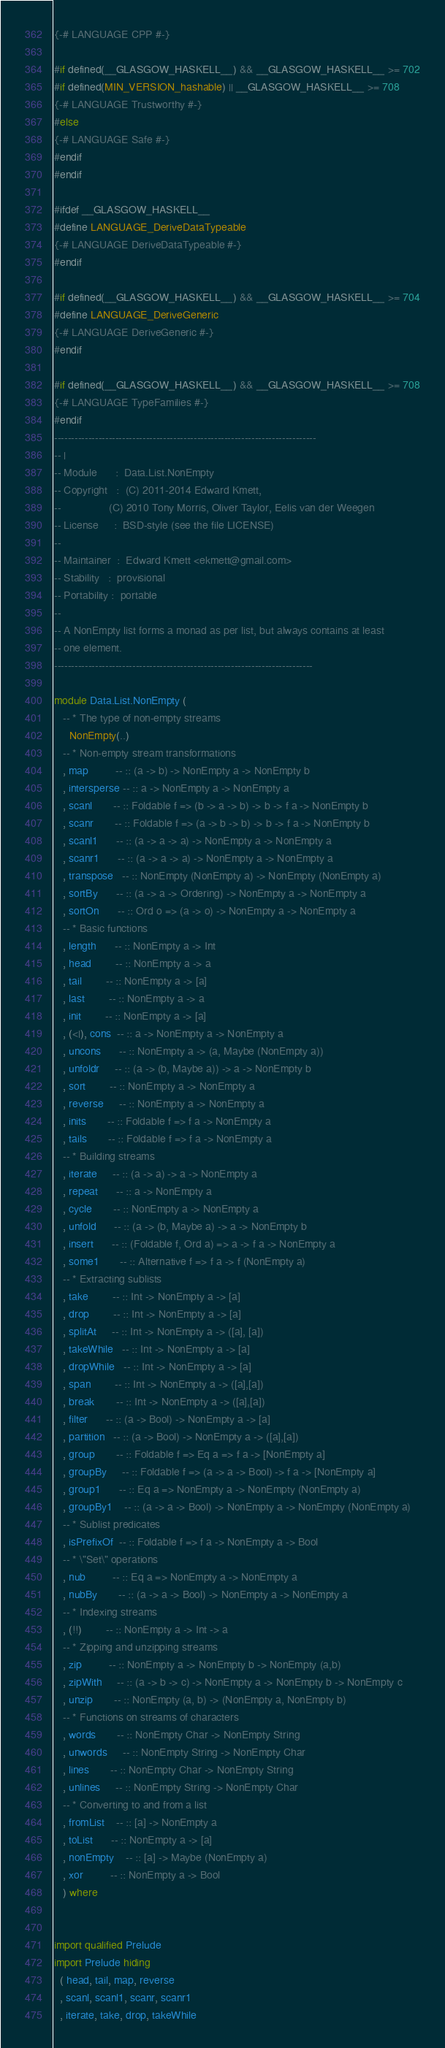<code> <loc_0><loc_0><loc_500><loc_500><_Haskell_>{-# LANGUAGE CPP #-}

#if defined(__GLASGOW_HASKELL__) && __GLASGOW_HASKELL__ >= 702
#if defined(MIN_VERSION_hashable) || __GLASGOW_HASKELL__ >= 708
{-# LANGUAGE Trustworthy #-}
#else
{-# LANGUAGE Safe #-}
#endif
#endif

#ifdef __GLASGOW_HASKELL__
#define LANGUAGE_DeriveDataTypeable
{-# LANGUAGE DeriveDataTypeable #-}
#endif

#if defined(__GLASGOW_HASKELL__) && __GLASGOW_HASKELL__ >= 704
#define LANGUAGE_DeriveGeneric
{-# LANGUAGE DeriveGeneric #-}
#endif

#if defined(__GLASGOW_HASKELL__) && __GLASGOW_HASKELL__ >= 708
{-# LANGUAGE TypeFamilies #-}
#endif
-----------------------------------------------------------------------------
-- |
-- Module      :  Data.List.NonEmpty
-- Copyright   :  (C) 2011-2014 Edward Kmett,
--                (C) 2010 Tony Morris, Oliver Taylor, Eelis van der Weegen
-- License     :  BSD-style (see the file LICENSE)
--
-- Maintainer  :  Edward Kmett <ekmett@gmail.com>
-- Stability   :  provisional
-- Portability :  portable
--
-- A NonEmpty list forms a monad as per list, but always contains at least
-- one element.
----------------------------------------------------------------------------

module Data.List.NonEmpty (
   -- * The type of non-empty streams
     NonEmpty(..)
   -- * Non-empty stream transformations
   , map         -- :: (a -> b) -> NonEmpty a -> NonEmpty b
   , intersperse -- :: a -> NonEmpty a -> NonEmpty a
   , scanl       -- :: Foldable f => (b -> a -> b) -> b -> f a -> NonEmpty b
   , scanr       -- :: Foldable f => (a -> b -> b) -> b -> f a -> NonEmpty b
   , scanl1      -- :: (a -> a -> a) -> NonEmpty a -> NonEmpty a
   , scanr1      -- :: (a -> a -> a) -> NonEmpty a -> NonEmpty a
   , transpose   -- :: NonEmpty (NonEmpty a) -> NonEmpty (NonEmpty a)
   , sortBy      -- :: (a -> a -> Ordering) -> NonEmpty a -> NonEmpty a
   , sortOn      -- :: Ord o => (a -> o) -> NonEmpty a -> NonEmpty a
   -- * Basic functions
   , length      -- :: NonEmpty a -> Int
   , head        -- :: NonEmpty a -> a
   , tail        -- :: NonEmpty a -> [a]
   , last        -- :: NonEmpty a -> a
   , init        -- :: NonEmpty a -> [a]
   , (<|), cons  -- :: a -> NonEmpty a -> NonEmpty a
   , uncons      -- :: NonEmpty a -> (a, Maybe (NonEmpty a))
   , unfoldr     -- :: (a -> (b, Maybe a)) -> a -> NonEmpty b
   , sort        -- :: NonEmpty a -> NonEmpty a
   , reverse     -- :: NonEmpty a -> NonEmpty a
   , inits       -- :: Foldable f => f a -> NonEmpty a
   , tails       -- :: Foldable f => f a -> NonEmpty a
   -- * Building streams
   , iterate     -- :: (a -> a) -> a -> NonEmpty a
   , repeat      -- :: a -> NonEmpty a
   , cycle       -- :: NonEmpty a -> NonEmpty a
   , unfold      -- :: (a -> (b, Maybe a) -> a -> NonEmpty b
   , insert      -- :: (Foldable f, Ord a) => a -> f a -> NonEmpty a
   , some1       -- :: Alternative f => f a -> f (NonEmpty a)
   -- * Extracting sublists
   , take        -- :: Int -> NonEmpty a -> [a]
   , drop        -- :: Int -> NonEmpty a -> [a]
   , splitAt     -- :: Int -> NonEmpty a -> ([a], [a])
   , takeWhile   -- :: Int -> NonEmpty a -> [a]
   , dropWhile   -- :: Int -> NonEmpty a -> [a]
   , span        -- :: Int -> NonEmpty a -> ([a],[a])
   , break       -- :: Int -> NonEmpty a -> ([a],[a])
   , filter      -- :: (a -> Bool) -> NonEmpty a -> [a]
   , partition   -- :: (a -> Bool) -> NonEmpty a -> ([a],[a])
   , group       -- :: Foldable f => Eq a => f a -> [NonEmpty a]
   , groupBy     -- :: Foldable f => (a -> a -> Bool) -> f a -> [NonEmpty a]
   , group1      -- :: Eq a => NonEmpty a -> NonEmpty (NonEmpty a)
   , groupBy1    -- :: (a -> a -> Bool) -> NonEmpty a -> NonEmpty (NonEmpty a)
   -- * Sublist predicates
   , isPrefixOf  -- :: Foldable f => f a -> NonEmpty a -> Bool
   -- * \"Set\" operations
   , nub         -- :: Eq a => NonEmpty a -> NonEmpty a
   , nubBy       -- :: (a -> a -> Bool) -> NonEmpty a -> NonEmpty a
   -- * Indexing streams
   , (!!)        -- :: NonEmpty a -> Int -> a
   -- * Zipping and unzipping streams
   , zip         -- :: NonEmpty a -> NonEmpty b -> NonEmpty (a,b)
   , zipWith     -- :: (a -> b -> c) -> NonEmpty a -> NonEmpty b -> NonEmpty c
   , unzip       -- :: NonEmpty (a, b) -> (NonEmpty a, NonEmpty b)
   -- * Functions on streams of characters
   , words       -- :: NonEmpty Char -> NonEmpty String
   , unwords     -- :: NonEmpty String -> NonEmpty Char
   , lines       -- :: NonEmpty Char -> NonEmpty String
   , unlines     -- :: NonEmpty String -> NonEmpty Char
   -- * Converting to and from a list
   , fromList    -- :: [a] -> NonEmpty a
   , toList      -- :: NonEmpty a -> [a]
   , nonEmpty    -- :: [a] -> Maybe (NonEmpty a)
   , xor         -- :: NonEmpty a -> Bool
   ) where


import qualified Prelude
import Prelude hiding
  ( head, tail, map, reverse
  , scanl, scanl1, scanr, scanr1
  , iterate, take, drop, takeWhile</code> 